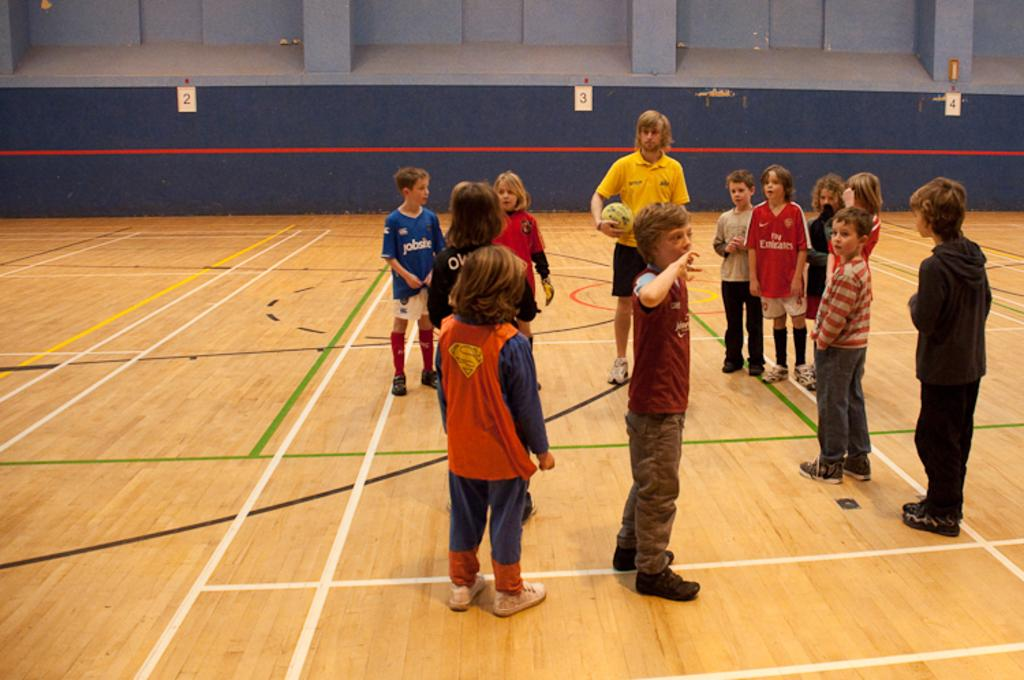What can be seen on the floor in the image? There are kids standing on the floor in the image. Who else is present in the image besides the kids? There is a person standing in the image. What is the person holding in his hand? The person is holding a ball in his hand. What type of organization does the minister represent in the image? There is no minister or organization present in the image. 